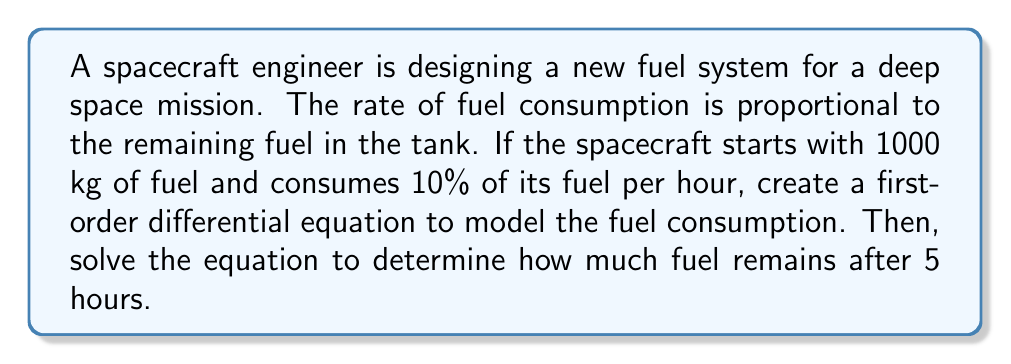Can you solve this math problem? Let's approach this step-by-step:

1) Let $F(t)$ be the amount of fuel remaining at time $t$ (in hours).

2) The rate of change of fuel is proportional to the amount of fuel remaining. This can be expressed as:

   $$\frac{dF}{dt} = -kF$$

   where $k$ is the proportionality constant.

3) We're told that 10% of fuel is consumed per hour. This means that $k = 0.1$.

4) Our differential equation becomes:

   $$\frac{dF}{dt} = -0.1F$$

5) This is a separable first-order differential equation. We can solve it as follows:

   $$\frac{dF}{F} = -0.1dt$$

6) Integrating both sides:

   $$\int \frac{dF}{F} = \int -0.1dt$$
   $$\ln|F| = -0.1t + C$$

7) Solving for $F$:

   $$F = e^{-0.1t + C} = Ae^{-0.1t}$$

   where $A = e^C$ is a constant.

8) We can find $A$ using the initial condition. At $t=0$, $F(0) = 1000$:

   $$1000 = Ae^{-0.1(0)} = A$$

9) Therefore, our solution is:

   $$F(t) = 1000e^{-0.1t}$$

10) To find the fuel remaining after 5 hours, we evaluate $F(5)$:

    $$F(5) = 1000e^{-0.1(5)} = 1000e^{-0.5} \approx 606.53$$
Answer: After 5 hours, approximately 606.53 kg of fuel remains in the spacecraft's tank. 